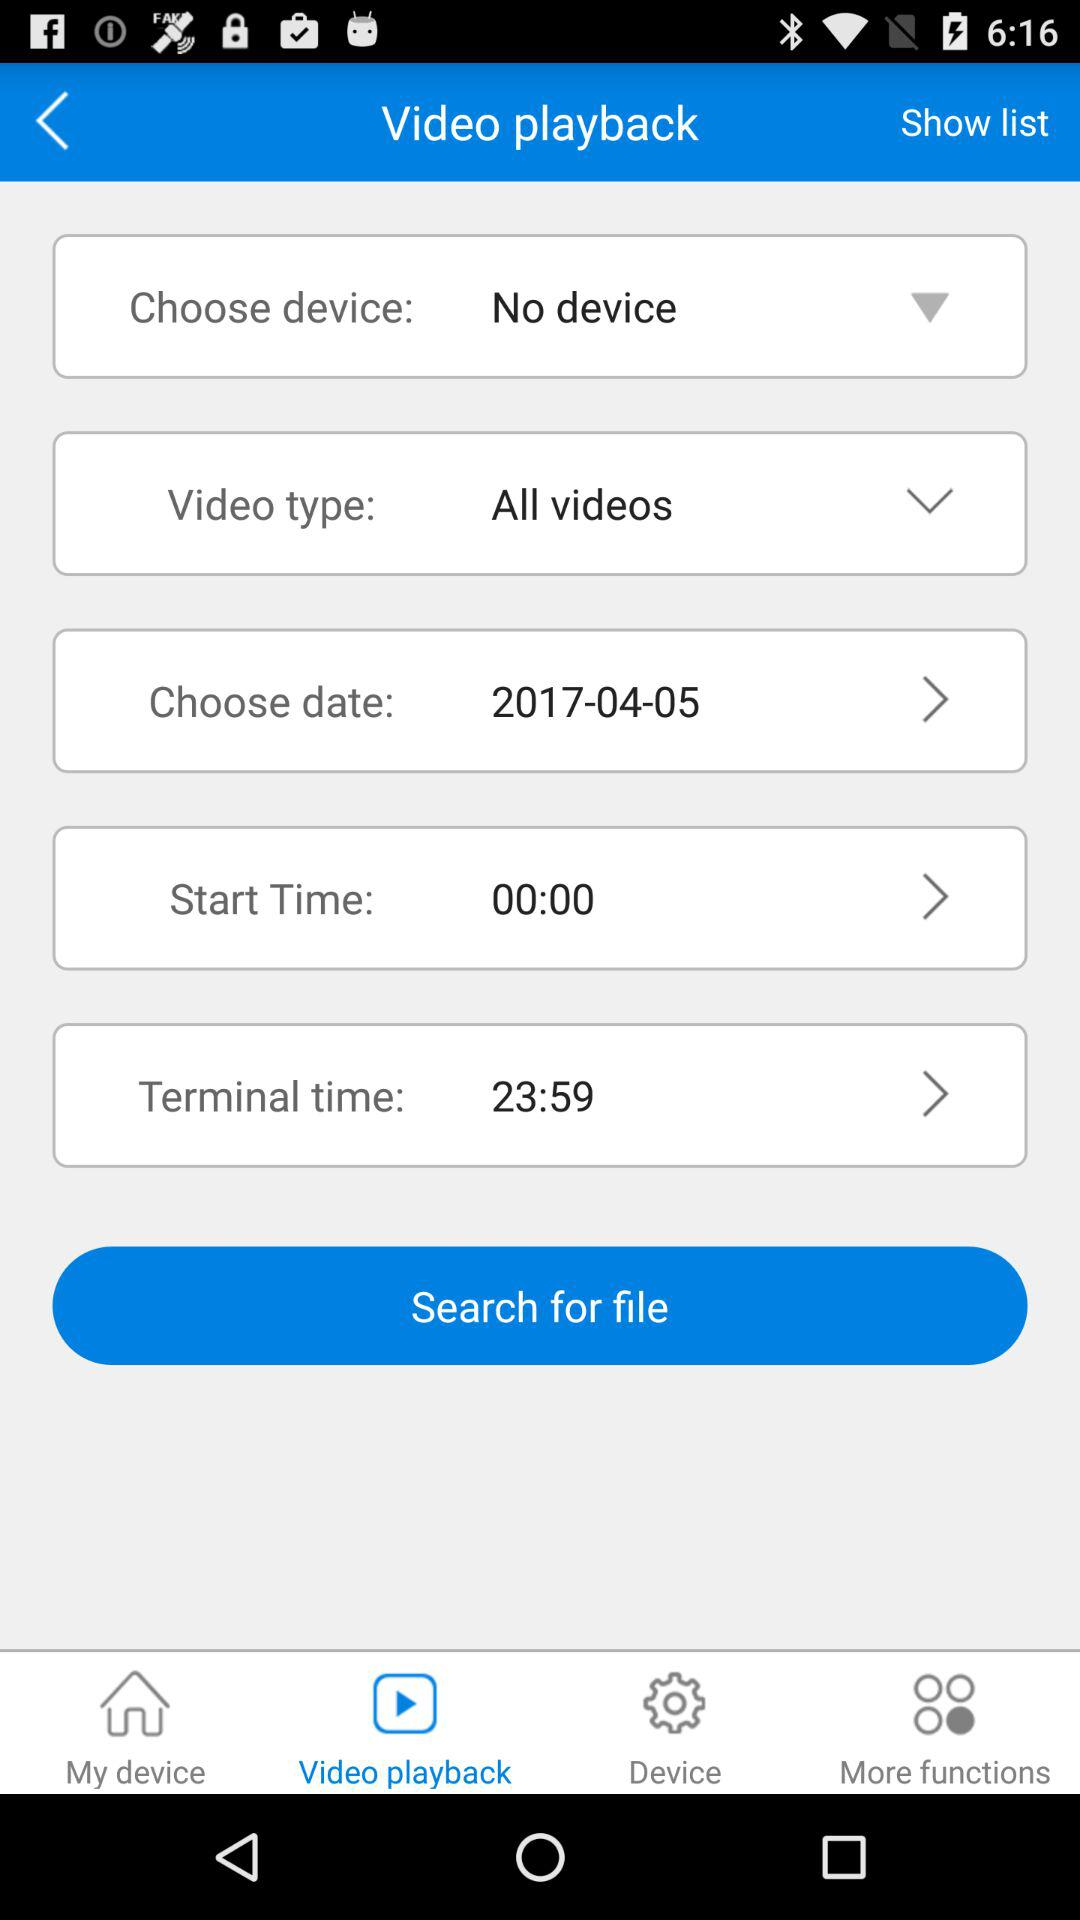Which tab is selected? The selected tab is "Video playback". 